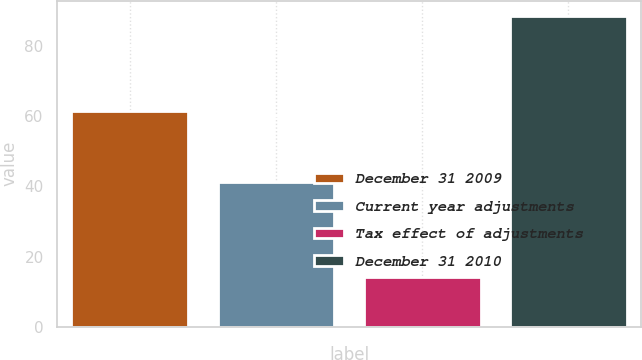Convert chart. <chart><loc_0><loc_0><loc_500><loc_500><bar_chart><fcel>December 31 2009<fcel>Current year adjustments<fcel>Tax effect of adjustments<fcel>December 31 2010<nl><fcel>61.5<fcel>41.2<fcel>14.2<fcel>88.5<nl></chart> 